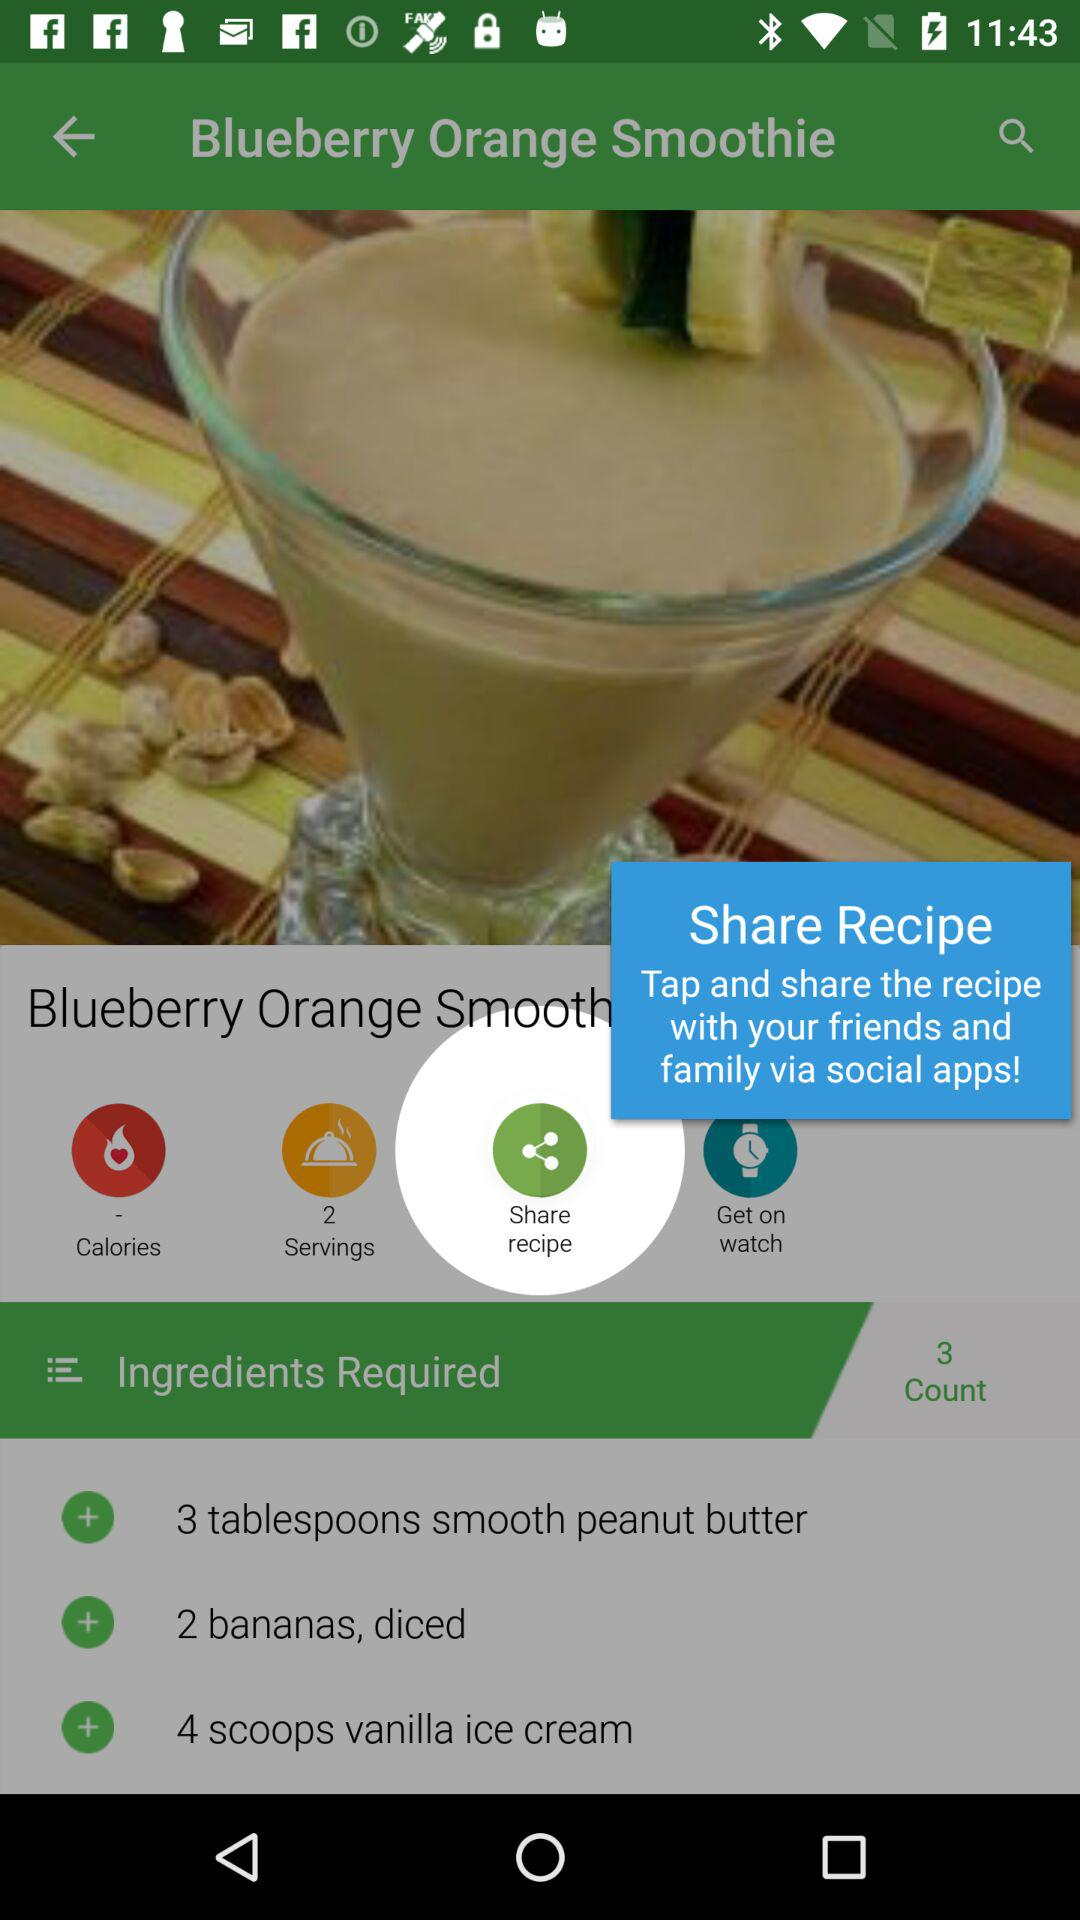What ingredients are required to make a "Blueberry Orange Smoothie"? The ingredients are "3 tablespoons smooth peanut butter", "2 bananas, diced", and "4 scoops vanilla ice cream". 